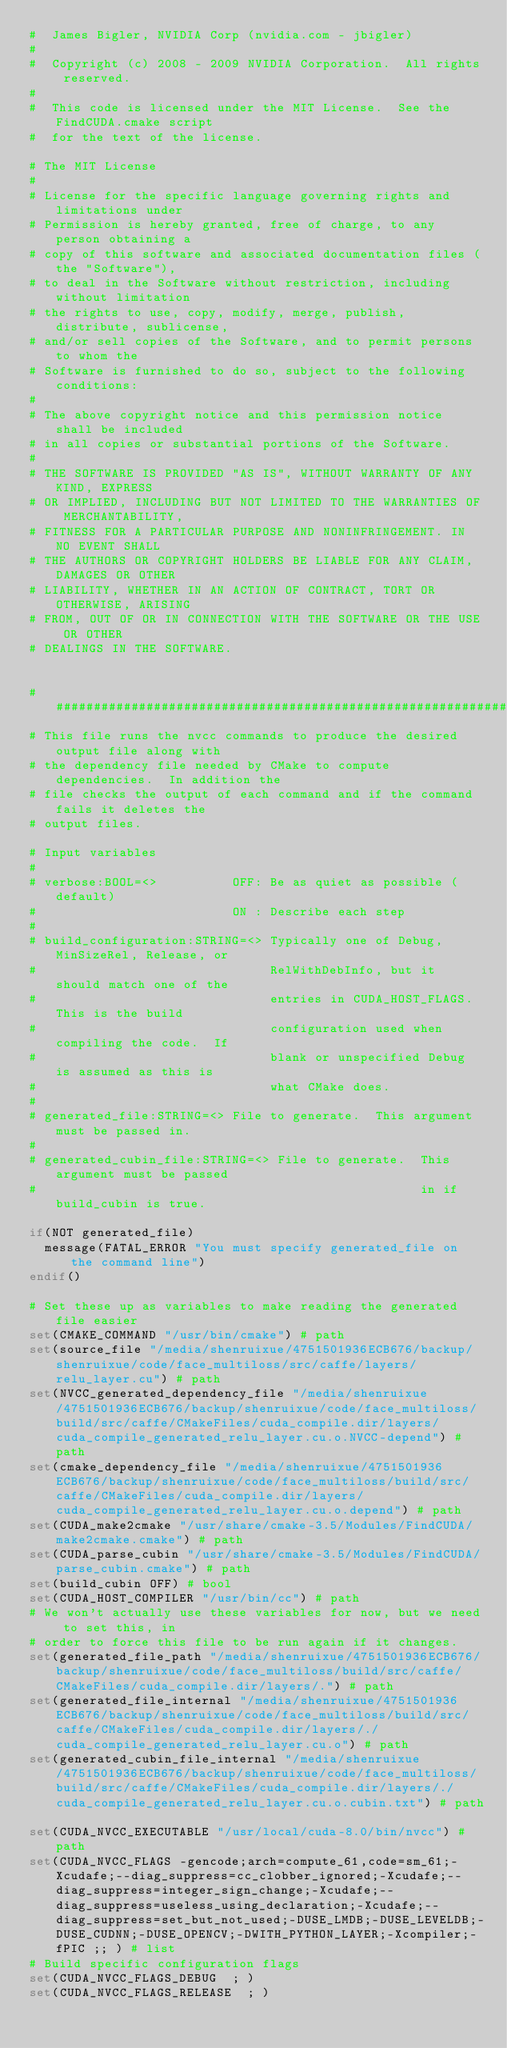Convert code to text. <code><loc_0><loc_0><loc_500><loc_500><_CMake_>#  James Bigler, NVIDIA Corp (nvidia.com - jbigler)
#
#  Copyright (c) 2008 - 2009 NVIDIA Corporation.  All rights reserved.
#
#  This code is licensed under the MIT License.  See the FindCUDA.cmake script
#  for the text of the license.

# The MIT License
#
# License for the specific language governing rights and limitations under
# Permission is hereby granted, free of charge, to any person obtaining a
# copy of this software and associated documentation files (the "Software"),
# to deal in the Software without restriction, including without limitation
# the rights to use, copy, modify, merge, publish, distribute, sublicense,
# and/or sell copies of the Software, and to permit persons to whom the
# Software is furnished to do so, subject to the following conditions:
#
# The above copyright notice and this permission notice shall be included
# in all copies or substantial portions of the Software.
#
# THE SOFTWARE IS PROVIDED "AS IS", WITHOUT WARRANTY OF ANY KIND, EXPRESS
# OR IMPLIED, INCLUDING BUT NOT LIMITED TO THE WARRANTIES OF MERCHANTABILITY,
# FITNESS FOR A PARTICULAR PURPOSE AND NONINFRINGEMENT. IN NO EVENT SHALL
# THE AUTHORS OR COPYRIGHT HOLDERS BE LIABLE FOR ANY CLAIM, DAMAGES OR OTHER
# LIABILITY, WHETHER IN AN ACTION OF CONTRACT, TORT OR OTHERWISE, ARISING
# FROM, OUT OF OR IN CONNECTION WITH THE SOFTWARE OR THE USE OR OTHER
# DEALINGS IN THE SOFTWARE.


##########################################################################
# This file runs the nvcc commands to produce the desired output file along with
# the dependency file needed by CMake to compute dependencies.  In addition the
# file checks the output of each command and if the command fails it deletes the
# output files.

# Input variables
#
# verbose:BOOL=<>          OFF: Be as quiet as possible (default)
#                          ON : Describe each step
#
# build_configuration:STRING=<> Typically one of Debug, MinSizeRel, Release, or
#                               RelWithDebInfo, but it should match one of the
#                               entries in CUDA_HOST_FLAGS. This is the build
#                               configuration used when compiling the code.  If
#                               blank or unspecified Debug is assumed as this is
#                               what CMake does.
#
# generated_file:STRING=<> File to generate.  This argument must be passed in.
#
# generated_cubin_file:STRING=<> File to generate.  This argument must be passed
#                                                   in if build_cubin is true.

if(NOT generated_file)
  message(FATAL_ERROR "You must specify generated_file on the command line")
endif()

# Set these up as variables to make reading the generated file easier
set(CMAKE_COMMAND "/usr/bin/cmake") # path
set(source_file "/media/shenruixue/4751501936ECB676/backup/shenruixue/code/face_multiloss/src/caffe/layers/relu_layer.cu") # path
set(NVCC_generated_dependency_file "/media/shenruixue/4751501936ECB676/backup/shenruixue/code/face_multiloss/build/src/caffe/CMakeFiles/cuda_compile.dir/layers/cuda_compile_generated_relu_layer.cu.o.NVCC-depend") # path
set(cmake_dependency_file "/media/shenruixue/4751501936ECB676/backup/shenruixue/code/face_multiloss/build/src/caffe/CMakeFiles/cuda_compile.dir/layers/cuda_compile_generated_relu_layer.cu.o.depend") # path
set(CUDA_make2cmake "/usr/share/cmake-3.5/Modules/FindCUDA/make2cmake.cmake") # path
set(CUDA_parse_cubin "/usr/share/cmake-3.5/Modules/FindCUDA/parse_cubin.cmake") # path
set(build_cubin OFF) # bool
set(CUDA_HOST_COMPILER "/usr/bin/cc") # path
# We won't actually use these variables for now, but we need to set this, in
# order to force this file to be run again if it changes.
set(generated_file_path "/media/shenruixue/4751501936ECB676/backup/shenruixue/code/face_multiloss/build/src/caffe/CMakeFiles/cuda_compile.dir/layers/.") # path
set(generated_file_internal "/media/shenruixue/4751501936ECB676/backup/shenruixue/code/face_multiloss/build/src/caffe/CMakeFiles/cuda_compile.dir/layers/./cuda_compile_generated_relu_layer.cu.o") # path
set(generated_cubin_file_internal "/media/shenruixue/4751501936ECB676/backup/shenruixue/code/face_multiloss/build/src/caffe/CMakeFiles/cuda_compile.dir/layers/./cuda_compile_generated_relu_layer.cu.o.cubin.txt") # path

set(CUDA_NVCC_EXECUTABLE "/usr/local/cuda-8.0/bin/nvcc") # path
set(CUDA_NVCC_FLAGS -gencode;arch=compute_61,code=sm_61;-Xcudafe;--diag_suppress=cc_clobber_ignored;-Xcudafe;--diag_suppress=integer_sign_change;-Xcudafe;--diag_suppress=useless_using_declaration;-Xcudafe;--diag_suppress=set_but_not_used;-DUSE_LMDB;-DUSE_LEVELDB;-DUSE_CUDNN;-DUSE_OPENCV;-DWITH_PYTHON_LAYER;-Xcompiler;-fPIC ;; ) # list
# Build specific configuration flags
set(CUDA_NVCC_FLAGS_DEBUG  ; )
set(CUDA_NVCC_FLAGS_RELEASE  ; )</code> 